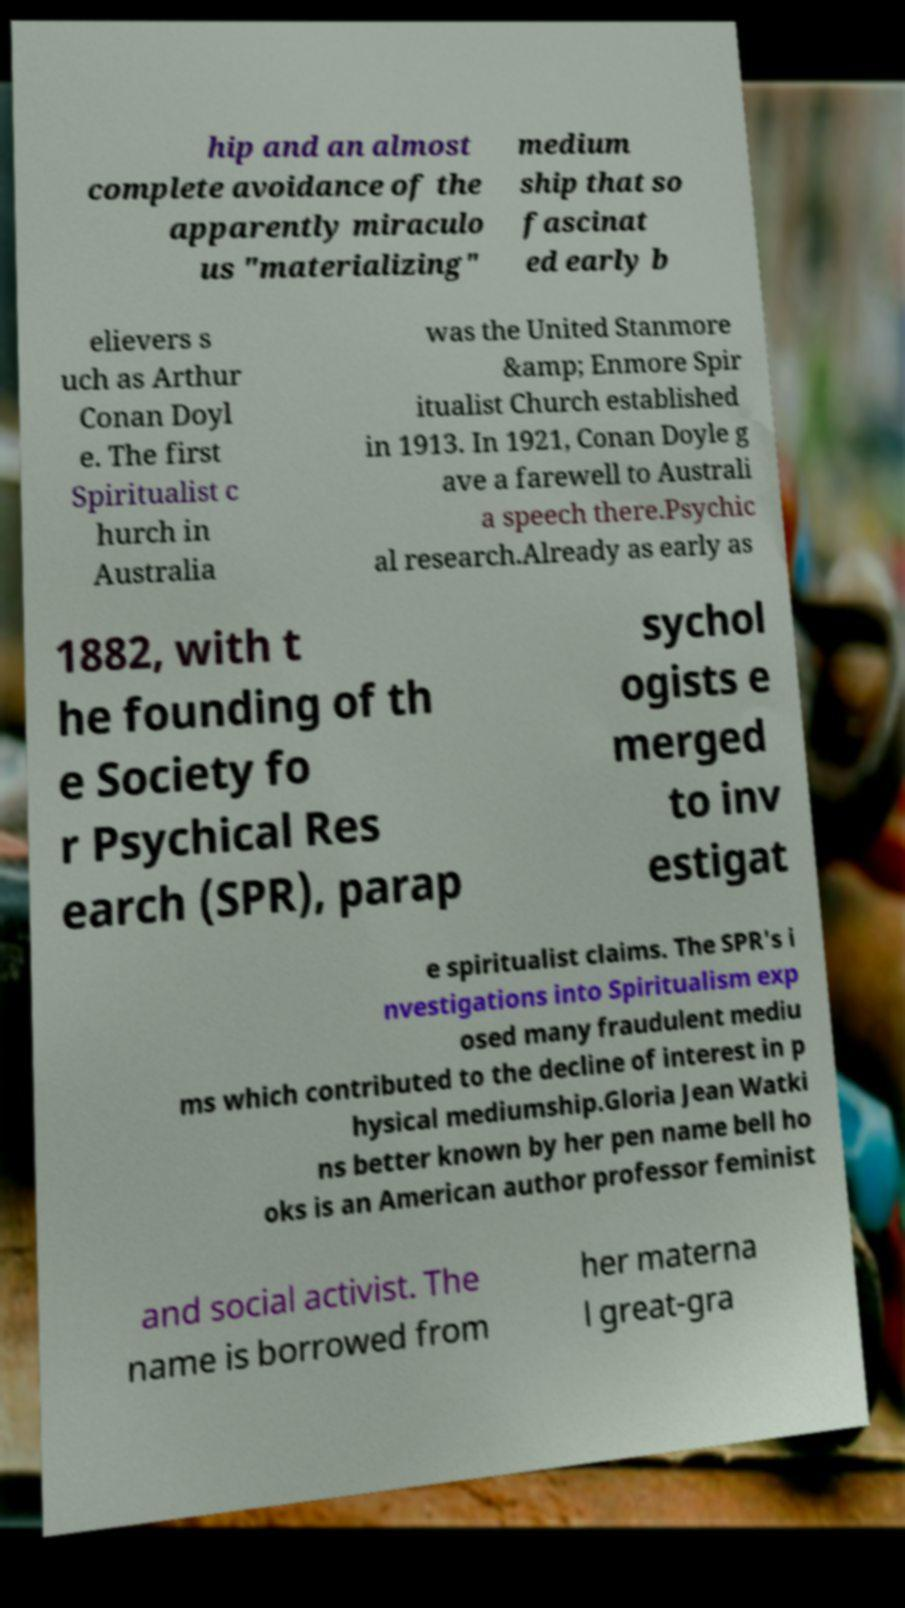Please read and relay the text visible in this image. What does it say? hip and an almost complete avoidance of the apparently miraculo us "materializing" medium ship that so fascinat ed early b elievers s uch as Arthur Conan Doyl e. The first Spiritualist c hurch in Australia was the United Stanmore &amp; Enmore Spir itualist Church established in 1913. In 1921, Conan Doyle g ave a farewell to Australi a speech there.Psychic al research.Already as early as 1882, with t he founding of th e Society fo r Psychical Res earch (SPR), parap sychol ogists e merged to inv estigat e spiritualist claims. The SPR's i nvestigations into Spiritualism exp osed many fraudulent mediu ms which contributed to the decline of interest in p hysical mediumship.Gloria Jean Watki ns better known by her pen name bell ho oks is an American author professor feminist and social activist. The name is borrowed from her materna l great-gra 